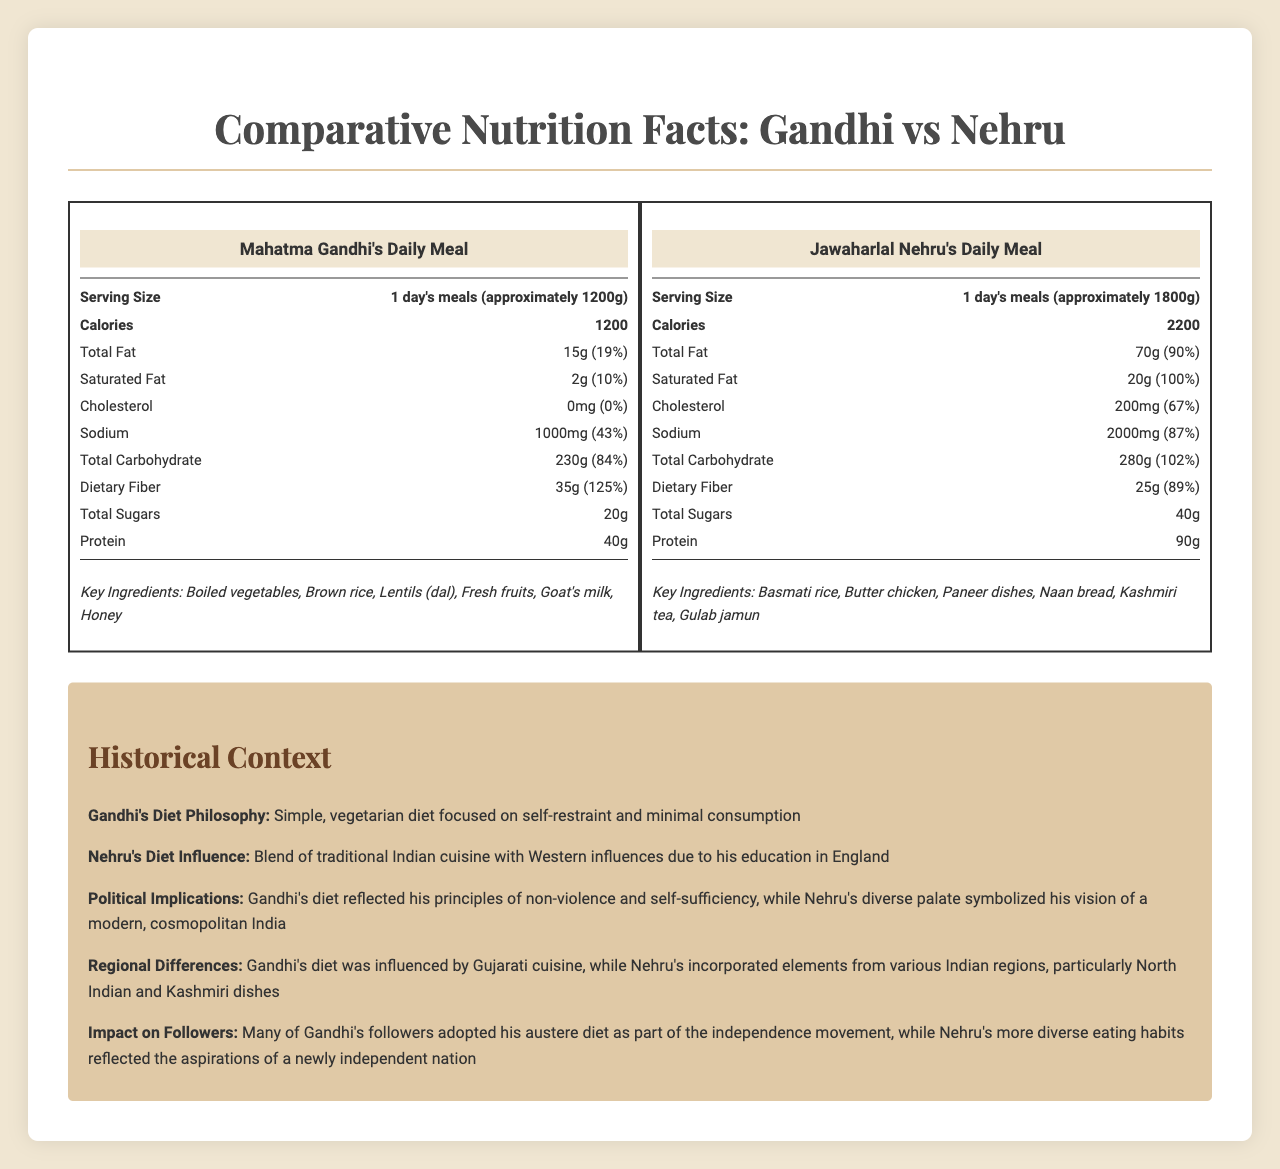What is the serving size for Mahatma Gandhi's daily meal? The document states that the serving size for Mahatma Gandhi's daily meal is "1 day's meals (approximately 1200g)".
Answer: 1 day's meals (approximately 1200g) How many calories are in Jawaharlal Nehru's daily meal? The document lists the calories in Jawaharlal Nehru's daily meal as 2200.
Answer: 2200 What is the total fat content in Mahatma Gandhi's daily meal? According to the document, the total fat content in Mahatma Gandhi's daily meal is 15g.
Answer: 15g Which of the following ingredients is not listed in Gandhi's daily meal? A. Boiled vegetables B. Basmati rice C. Goat's milk The ingredients listed for Gandhi's meal are boiled vegetables, brown rice, lentils (dal), fresh fruits, goat's milk, and honey. Basmati rice is not included.
Answer: B. Basmati rice Does Nehru's meal include trans fat? The document explicitly states that Nehru's meal includes 0g of trans fat.
Answer: No What percentage of the daily value of Saturated Fat does Nehru's meal contain? Nehru's meal includes 20g of saturated fat which is 100% of the daily value.
Answer: 100% Which meal has a higher protein content? The protein content of Nehru's meal is 90g while Gandhi's meal has 40g of protein.
Answer: Nehru's meal How much dietary fiber is in Gandhi's daily meal? Gandhi's daily meal contains 35g of dietary fiber as mentioned in the document.
Answer: 35g Which meal has a higher sodium content? A. Gandhi's meal B. Nehru's meal The sodium content in Nehru's meal is 2000mg while in Gandhi's meal it is 1000mg.
Answer: B. Nehru's meal True or False: Gandhi's diet philosophy focuses on self-restraint and minimal consumption. The document mentions that Gandhi's diet philosophy is a simple, vegetarian diet focused on self-restraint and minimal consumption.
Answer: True What is the historical significance of the dietary differences between Gandhi and Nehru's meals? The document states that Gandhi's diet principles were aligned with non-violence and self-sufficiency, and Nehru's diverse eating habits reflected his vision for a modern and cosmopolitan India.
Answer: Gandhi's diet reflects his principles of non-violence and self-sufficiency while Nehru's diet symbolizes his vision of a modern, cosmopolitan India. What are the primary carbohydrates listed for Gandhi's meal? The primary carbohydrate sources for Gandhi's meal are brown rice, lentils (dal), and fresh fruits as per the document.
Answer: Brown rice, Lentils (dal), Fresh fruits What percentage of daily value of calcium does Nehru's meal provide? Nehru's meal provides 35% of the daily value of calcium as listed in the document.
Answer: 35% Can you determine the exact daily diet plan that Gandhi followed including meal timing? The document provides information about the nutritional content and key ingredients of Gandhi's meal but does not specify the exact daily diet plan or meal timings.
Answer: Cannot be determined Summarize the document. The document gives a detailed comparative nutritional analysis of the typical daily meals of Mahatma Gandhi and Jawaharlal Nehru, including the nutritional values, key ingredients, and historical contexts that influenced their dietary choices. Gandhi's diet is described as simple and vegetarian, stressing minimal consumption and self-restraint, reflecting his principles of non-violence. Nehru's diet, on the other hand, is richer and more diverse, symbolizing his modern and cosmopolitan vision for India, influenced by his time in England and incorporating regional and Western elements. The historical context section further outlines how these dietary habits mirrored their political and philosophical beliefs and impacted their followers.
Answer: The document provides a comparative analysis of the nutrition facts between Mahatma Gandhi's and Jawaharlal Nehru's typical daily meals, emphasizing the dietary and philosophical differences. Gandhi's diet is simpler, vegetarian, and reflects his principles of non-violence and self-restraint, while Nehru's diet is richer, more varied, blending traditional Indian cuisine with Western influences, symbolizing his vision of a modern nation. The historical context highlights the political implications and the influence on their followers. 